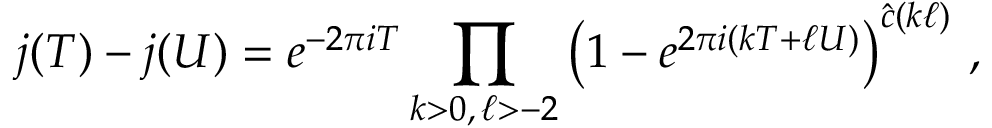<formula> <loc_0><loc_0><loc_500><loc_500>j ( T ) - j ( U ) = e ^ { - 2 \pi i T } \prod _ { k > 0 , \, \ell > - 2 } \left ( 1 - e ^ { 2 \pi i ( k T + \ell U ) } \right ) ^ { \hat { c } ( k \ell ) } \, ,</formula> 